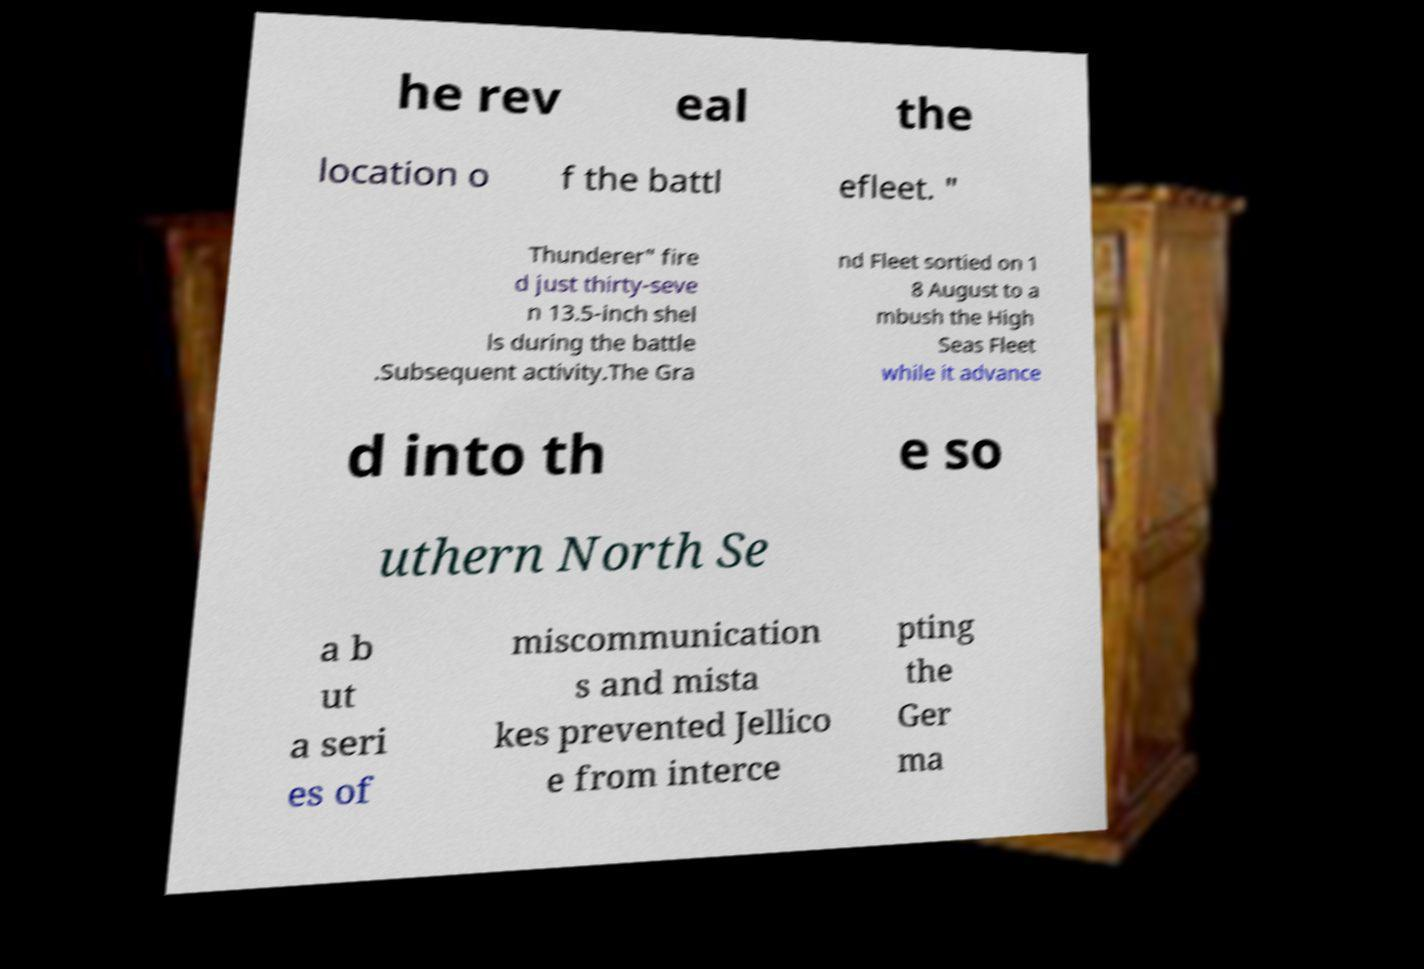What messages or text are displayed in this image? I need them in a readable, typed format. he rev eal the location o f the battl efleet. " Thunderer" fire d just thirty-seve n 13.5-inch shel ls during the battle .Subsequent activity.The Gra nd Fleet sortied on 1 8 August to a mbush the High Seas Fleet while it advance d into th e so uthern North Se a b ut a seri es of miscommunication s and mista kes prevented Jellico e from interce pting the Ger ma 